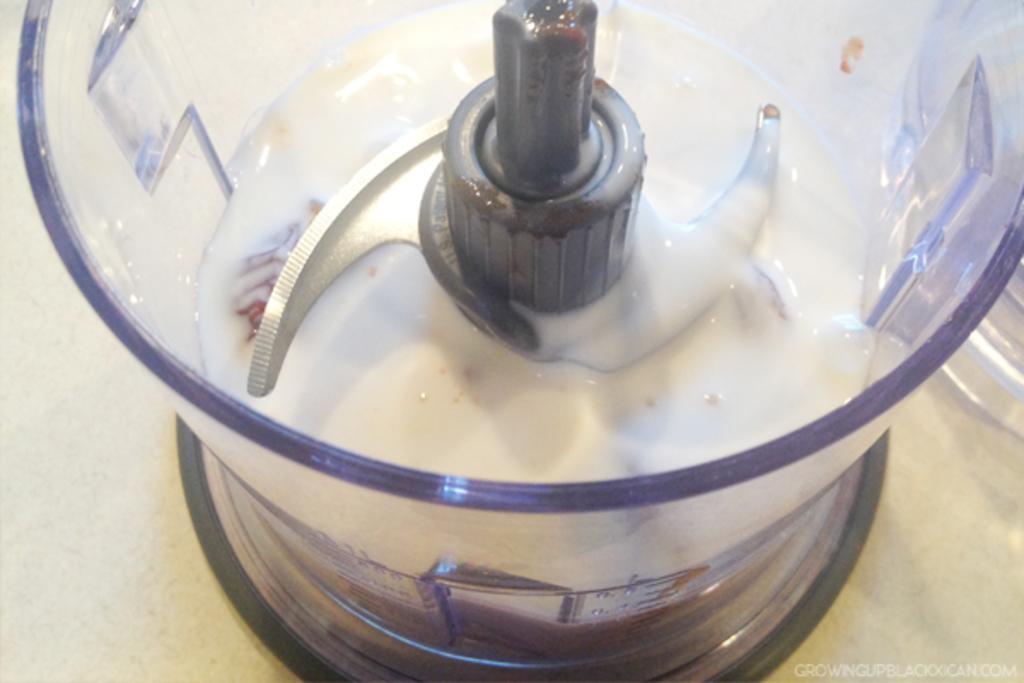Could you give a brief overview of what you see in this image? In this image we can see some white color liquid in a juicer which is on the surface. In the bottom right corner there is text. 